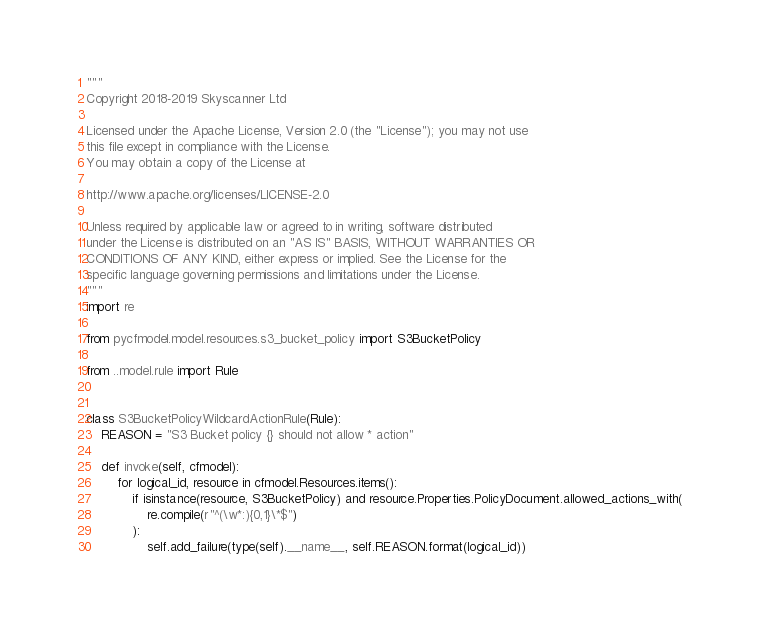<code> <loc_0><loc_0><loc_500><loc_500><_Python_>"""
Copyright 2018-2019 Skyscanner Ltd

Licensed under the Apache License, Version 2.0 (the "License"); you may not use
this file except in compliance with the License.
You may obtain a copy of the License at

http://www.apache.org/licenses/LICENSE-2.0

Unless required by applicable law or agreed to in writing, software distributed
under the License is distributed on an "AS IS" BASIS, WITHOUT WARRANTIES OR
CONDITIONS OF ANY KIND, either express or implied. See the License for the
specific language governing permissions and limitations under the License.
"""
import re

from pycfmodel.model.resources.s3_bucket_policy import S3BucketPolicy

from ..model.rule import Rule


class S3BucketPolicyWildcardActionRule(Rule):
    REASON = "S3 Bucket policy {} should not allow * action"

    def invoke(self, cfmodel):
        for logical_id, resource in cfmodel.Resources.items():
            if isinstance(resource, S3BucketPolicy) and resource.Properties.PolicyDocument.allowed_actions_with(
                re.compile(r"^(\w*:){0,1}\*$")
            ):
                self.add_failure(type(self).__name__, self.REASON.format(logical_id))
</code> 